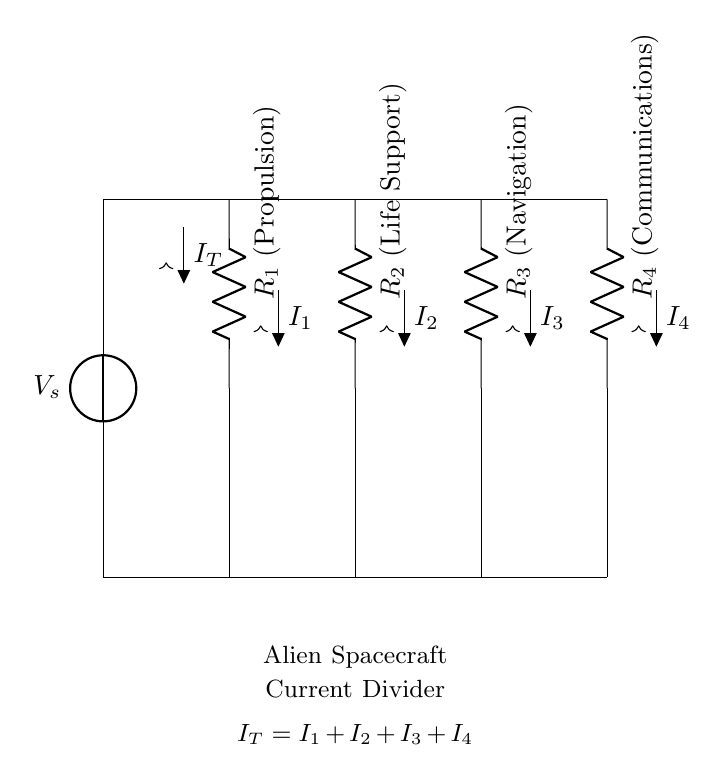What is the source voltage in this circuit? The source voltage, labeled V_s, is positioned at the top of the circuit where it connects to the resistors. It provides the total voltage to the current divider.
Answer: V_s How many resistors are present in the circuit? The diagram shows four resistors represented as R1, R2, R3, and R4, each connected in parallel to the source voltage.
Answer: Four What do the resistors R1, R2, R3, and R4 power? R1 powers the propulsion system, R2 powers the life support, R3 powers navigation, and R4 powers communications. Each resistor has a specific labeled function in the diagram.
Answer: Propulsion, Life Support, Navigation, Communications What is the total current flowing into the current divider? The total current, labeled I_T, is indicated at the top of the circuit just before the current splits into the branches of the four resistors. It represents the incoming current from the source.
Answer: I_T How is the relationship between total current and branch currents expressed? The relationship is given by the equation I_T = I_1 + I_2 + I_3 + I_4, indicating that the total current entering the divider is the sum of the currents through each resistor.
Answer: I_T = I_1 + I_2 + I_3 + I_4 What type of circuit is represented here? This circuit is a current divider circuit, which is specifically designed to distribute the total current into multiple paths through the resistors.
Answer: Current Divider 